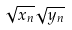Convert formula to latex. <formula><loc_0><loc_0><loc_500><loc_500>\sqrt { x _ { n } } \sqrt { y _ { n } }</formula> 